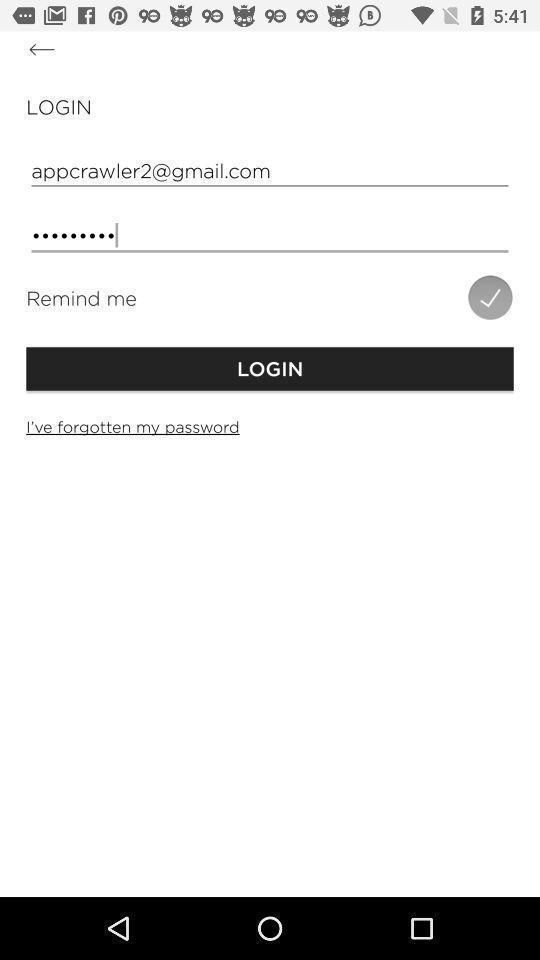What can you discern from this picture? Page showing log in credentials. 